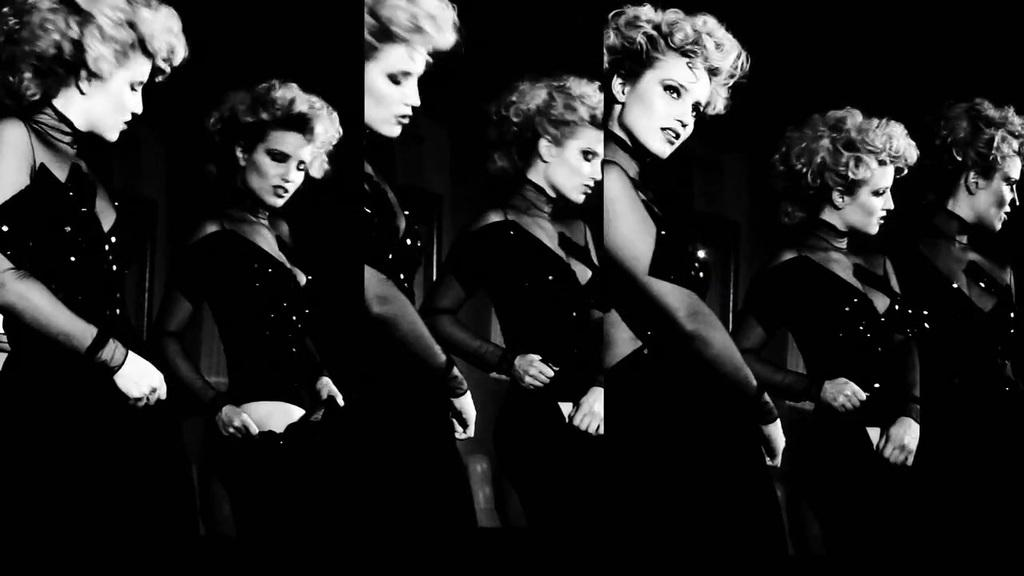What is the color scheme of the image? The image is black and white. How many people are in the image? There are two women in the image. What are the women wearing? Both women are wearing black dresses. How are the women positioned in the image? The women are shown in different angles. Is there any quicksand present in the image? No, there is no quicksand present in the image. What type of sorting activity are the women engaged in within the image? The image does not depict any sorting activity; it shows two women wearing black dresses in different angles. 